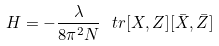Convert formula to latex. <formula><loc_0><loc_0><loc_500><loc_500>H = - \frac { \lambda } { 8 \pi ^ { 2 } N } \ t r [ X , Z ] [ \bar { X } , \bar { Z } ]</formula> 